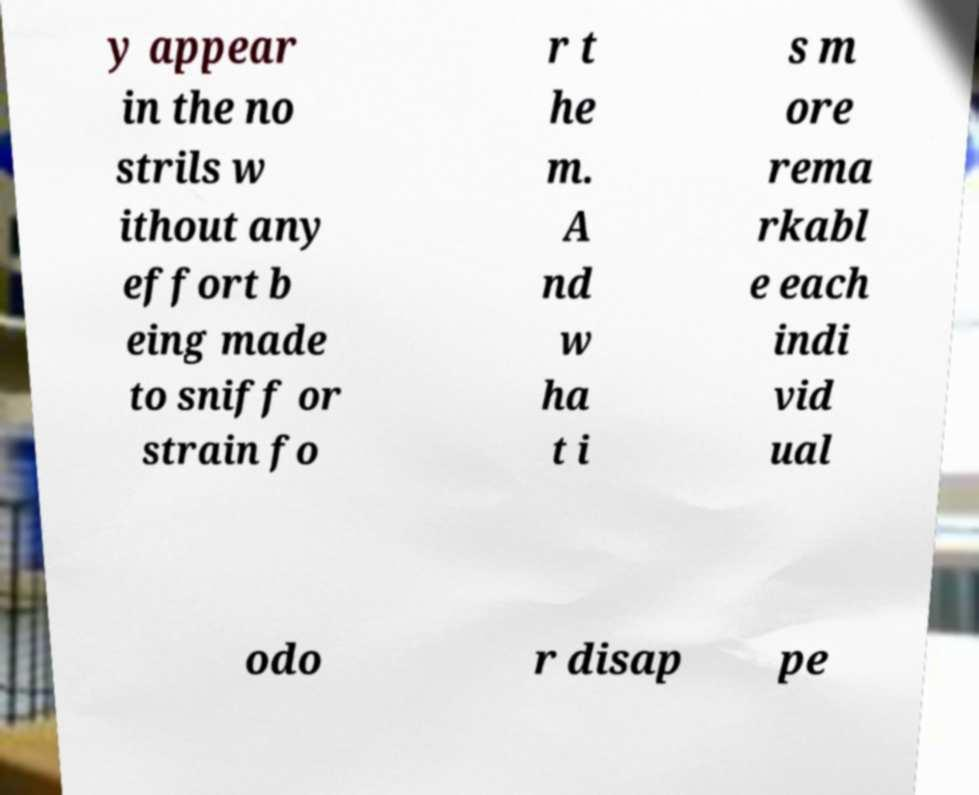Could you extract and type out the text from this image? y appear in the no strils w ithout any effort b eing made to sniff or strain fo r t he m. A nd w ha t i s m ore rema rkabl e each indi vid ual odo r disap pe 